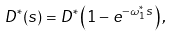<formula> <loc_0><loc_0><loc_500><loc_500>D ^ { \ast } ( s ) = D ^ { \ast } \left ( 1 - e ^ { - \omega _ { 1 } ^ { \ast } s } \right ) ,</formula> 